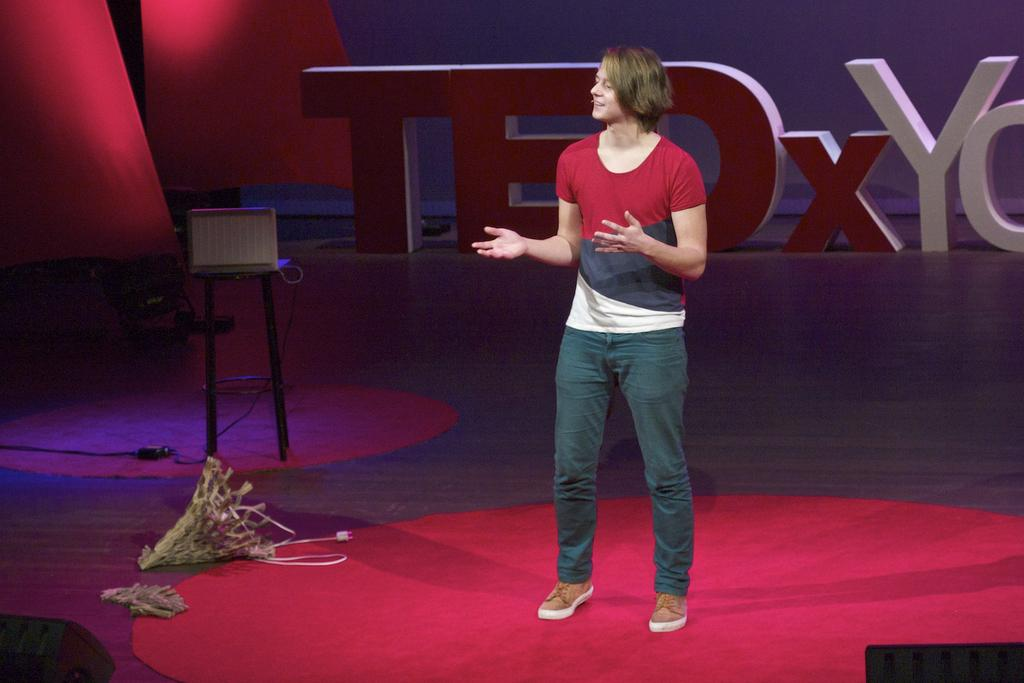What is happening on the stage in the image? There is a person standing on the stage. What is located beside the person on the stage? There is a bouquet beside the person. What object can be seen on a table in the image? There is a laptop on a table. What can be read or seen at the back of the stage? There is some text visible at the back of the stage. How much wealth does the person on the stage possess, as indicated by the image? The image does not provide any information about the person's wealth. What rule is being enforced or followed by the person on the stage, as seen in the image? The image does not show any rules being enforced or followed by the person on the stage. 